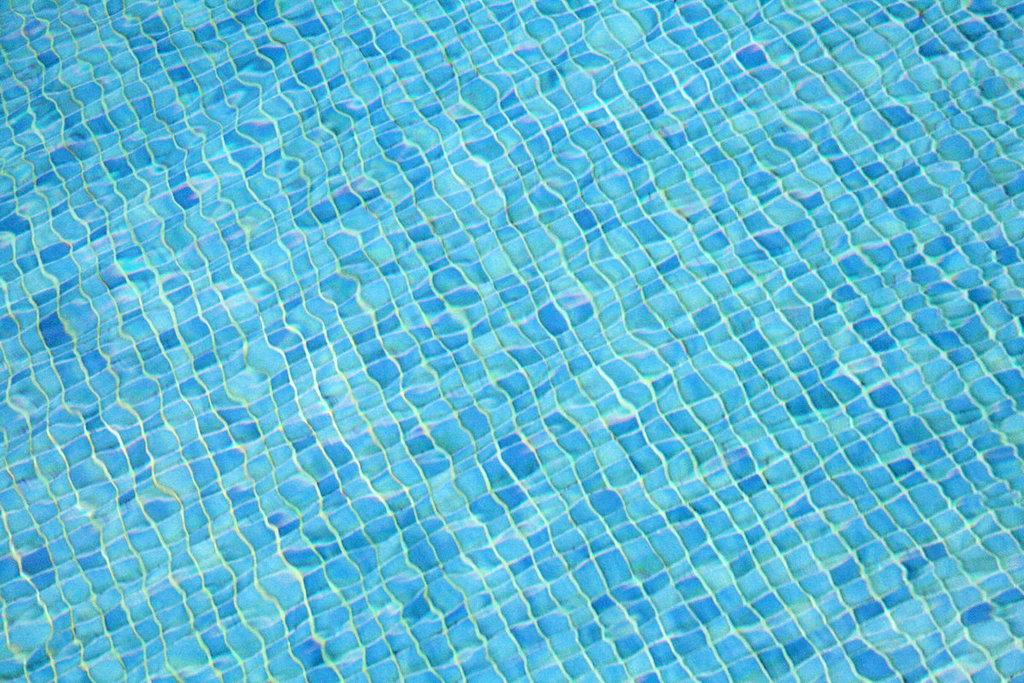What is visible in the image? There is water and a surface with tiles of dark and light blue colors in the image. Can you describe the surface in the image? The surface has tiles of dark and light blue colors. How many bananas are on the surface in the image? There are no bananas present in the image. What type of mask is being worn by the person in the image? There is no person or mask present in the image. 